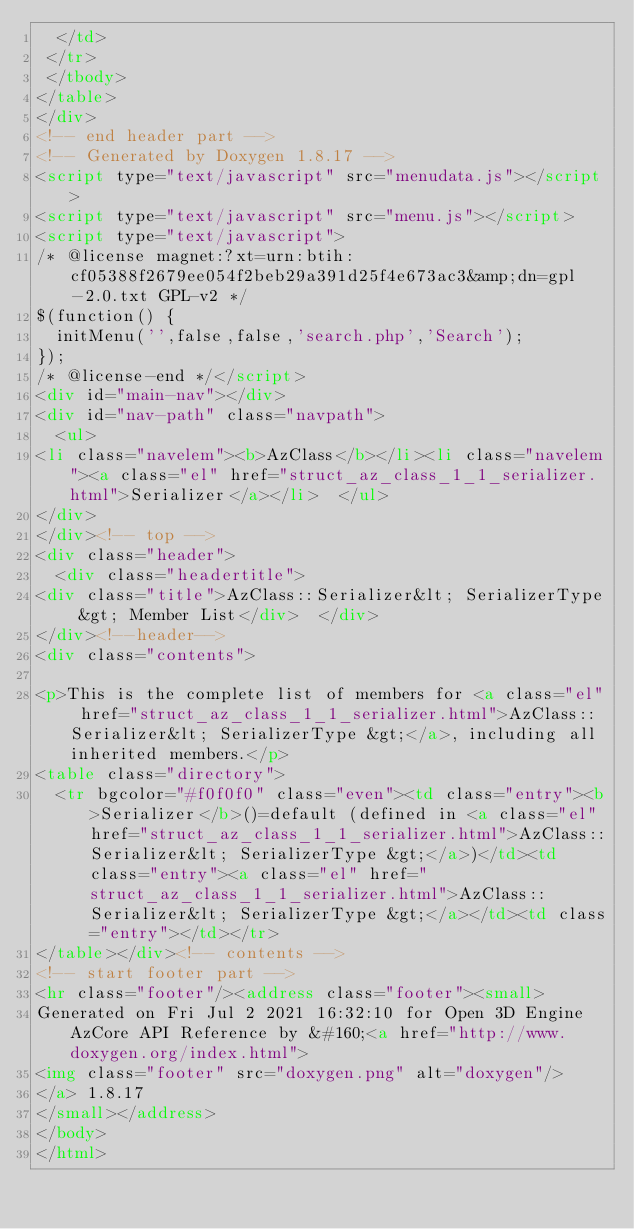Convert code to text. <code><loc_0><loc_0><loc_500><loc_500><_HTML_>  </td>
 </tr>
 </tbody>
</table>
</div>
<!-- end header part -->
<!-- Generated by Doxygen 1.8.17 -->
<script type="text/javascript" src="menudata.js"></script>
<script type="text/javascript" src="menu.js"></script>
<script type="text/javascript">
/* @license magnet:?xt=urn:btih:cf05388f2679ee054f2beb29a391d25f4e673ac3&amp;dn=gpl-2.0.txt GPL-v2 */
$(function() {
  initMenu('',false,false,'search.php','Search');
});
/* @license-end */</script>
<div id="main-nav"></div>
<div id="nav-path" class="navpath">
  <ul>
<li class="navelem"><b>AzClass</b></li><li class="navelem"><a class="el" href="struct_az_class_1_1_serializer.html">Serializer</a></li>  </ul>
</div>
</div><!-- top -->
<div class="header">
  <div class="headertitle">
<div class="title">AzClass::Serializer&lt; SerializerType &gt; Member List</div>  </div>
</div><!--header-->
<div class="contents">

<p>This is the complete list of members for <a class="el" href="struct_az_class_1_1_serializer.html">AzClass::Serializer&lt; SerializerType &gt;</a>, including all inherited members.</p>
<table class="directory">
  <tr bgcolor="#f0f0f0" class="even"><td class="entry"><b>Serializer</b>()=default (defined in <a class="el" href="struct_az_class_1_1_serializer.html">AzClass::Serializer&lt; SerializerType &gt;</a>)</td><td class="entry"><a class="el" href="struct_az_class_1_1_serializer.html">AzClass::Serializer&lt; SerializerType &gt;</a></td><td class="entry"></td></tr>
</table></div><!-- contents -->
<!-- start footer part -->
<hr class="footer"/><address class="footer"><small>
Generated on Fri Jul 2 2021 16:32:10 for Open 3D Engine AzCore API Reference by &#160;<a href="http://www.doxygen.org/index.html">
<img class="footer" src="doxygen.png" alt="doxygen"/>
</a> 1.8.17
</small></address>
</body>
</html>
</code> 